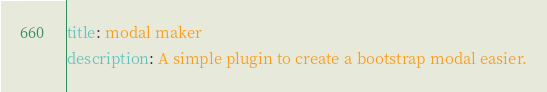Convert code to text. <code><loc_0><loc_0><loc_500><loc_500><_YAML_>title: modal maker
description: A simple plugin to create a bootstrap modal easier.</code> 